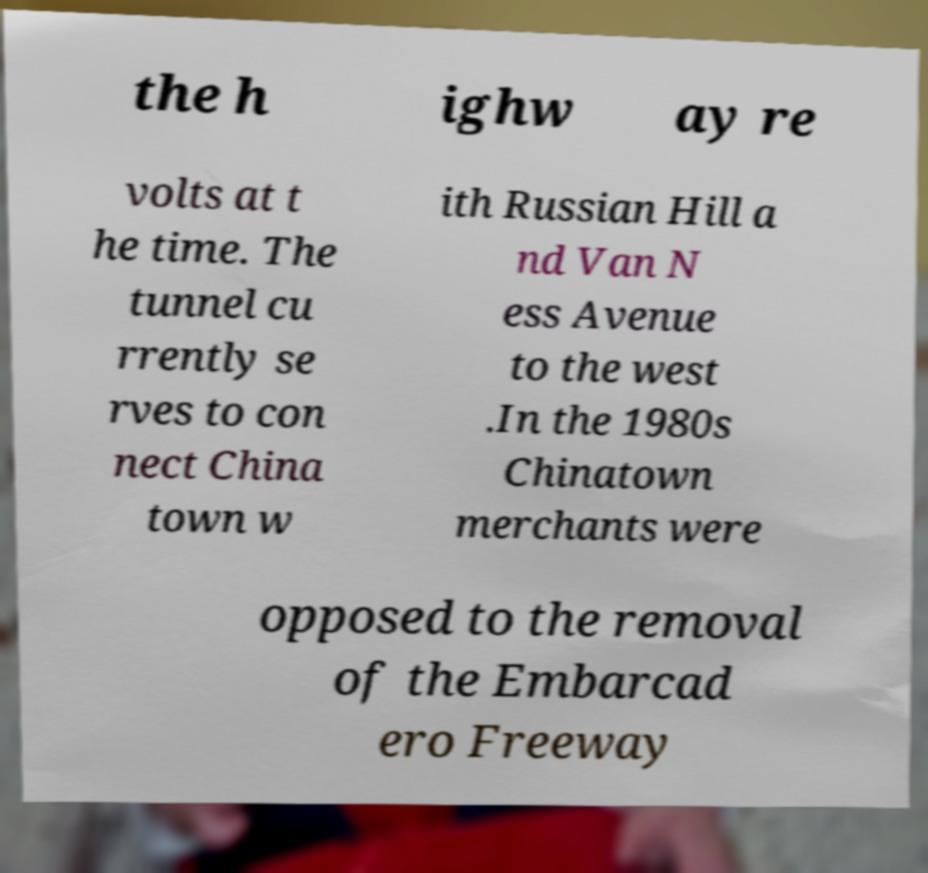Can you accurately transcribe the text from the provided image for me? the h ighw ay re volts at t he time. The tunnel cu rrently se rves to con nect China town w ith Russian Hill a nd Van N ess Avenue to the west .In the 1980s Chinatown merchants were opposed to the removal of the Embarcad ero Freeway 